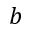<formula> <loc_0><loc_0><loc_500><loc_500>b</formula> 